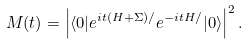Convert formula to latex. <formula><loc_0><loc_0><loc_500><loc_500>M ( t ) = \left | \langle 0 | e ^ { i t ( H + \Sigma ) / } e ^ { - i t H / } | 0 \rangle \right | ^ { 2 } .</formula> 